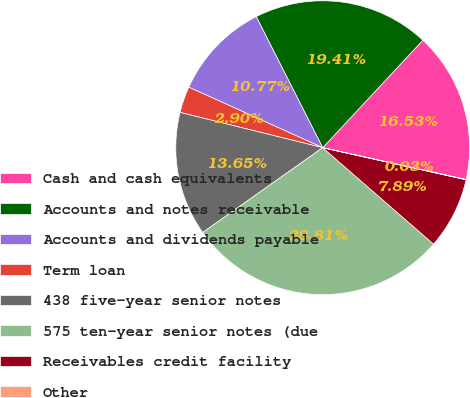Convert chart to OTSL. <chart><loc_0><loc_0><loc_500><loc_500><pie_chart><fcel>Cash and cash equivalents<fcel>Accounts and notes receivable<fcel>Accounts and dividends payable<fcel>Term loan<fcel>438 five-year senior notes<fcel>575 ten-year senior notes (due<fcel>Receivables credit facility<fcel>Other<nl><fcel>16.53%<fcel>19.41%<fcel>10.77%<fcel>2.9%<fcel>13.65%<fcel>28.81%<fcel>7.89%<fcel>0.03%<nl></chart> 